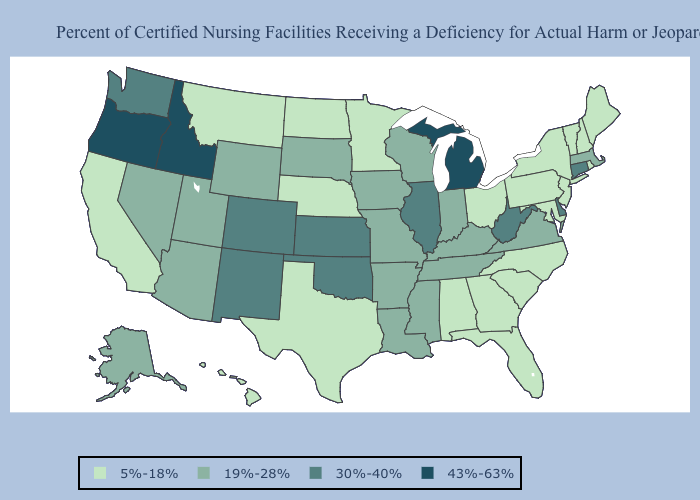Name the states that have a value in the range 30%-40%?
Answer briefly. Colorado, Connecticut, Delaware, Illinois, Kansas, New Mexico, Oklahoma, Washington, West Virginia. Does Nevada have the highest value in the West?
Give a very brief answer. No. Among the states that border Idaho , does Utah have the highest value?
Answer briefly. No. Which states have the lowest value in the USA?
Answer briefly. Alabama, California, Florida, Georgia, Hawaii, Maine, Maryland, Minnesota, Montana, Nebraska, New Hampshire, New Jersey, New York, North Carolina, North Dakota, Ohio, Pennsylvania, Rhode Island, South Carolina, Texas, Vermont. Name the states that have a value in the range 30%-40%?
Be succinct. Colorado, Connecticut, Delaware, Illinois, Kansas, New Mexico, Oklahoma, Washington, West Virginia. What is the value of North Carolina?
Concise answer only. 5%-18%. Does Arizona have the lowest value in the USA?
Be succinct. No. Which states have the lowest value in the USA?
Keep it brief. Alabama, California, Florida, Georgia, Hawaii, Maine, Maryland, Minnesota, Montana, Nebraska, New Hampshire, New Jersey, New York, North Carolina, North Dakota, Ohio, Pennsylvania, Rhode Island, South Carolina, Texas, Vermont. What is the highest value in the MidWest ?
Be succinct. 43%-63%. Name the states that have a value in the range 19%-28%?
Give a very brief answer. Alaska, Arizona, Arkansas, Indiana, Iowa, Kentucky, Louisiana, Massachusetts, Mississippi, Missouri, Nevada, South Dakota, Tennessee, Utah, Virginia, Wisconsin, Wyoming. What is the value of Ohio?
Give a very brief answer. 5%-18%. Which states hav the highest value in the Northeast?
Answer briefly. Connecticut. What is the value of Connecticut?
Keep it brief. 30%-40%. What is the lowest value in the USA?
Write a very short answer. 5%-18%. Which states have the highest value in the USA?
Answer briefly. Idaho, Michigan, Oregon. 